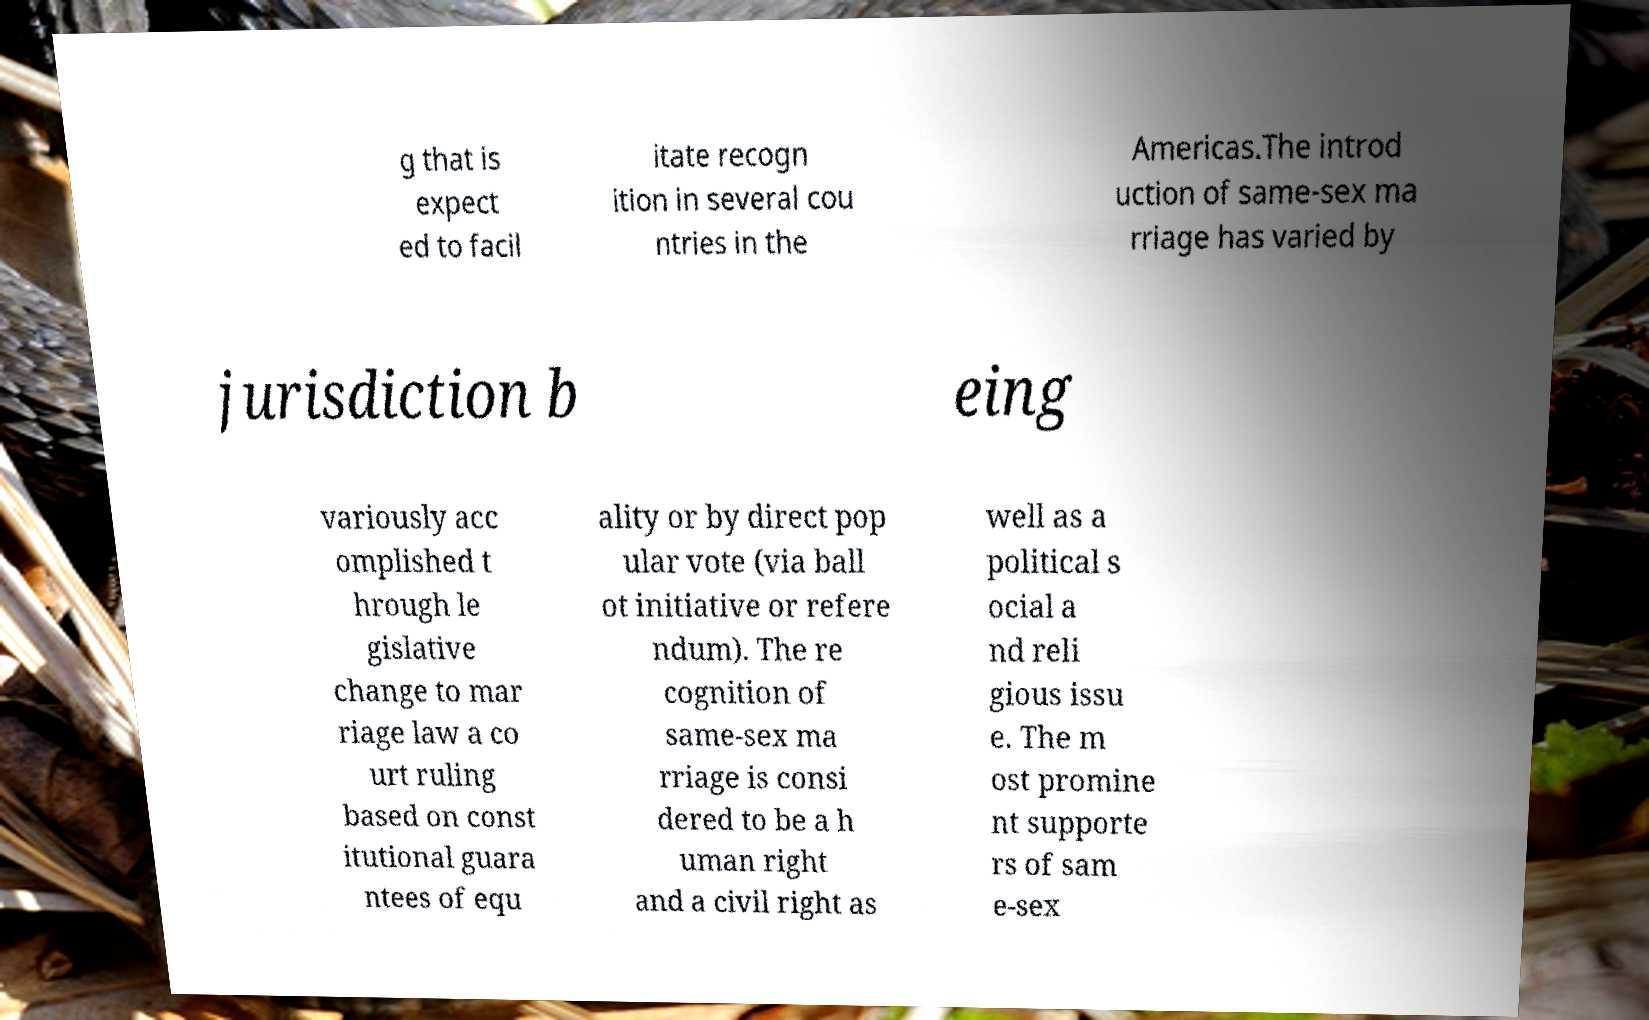There's text embedded in this image that I need extracted. Can you transcribe it verbatim? g that is expect ed to facil itate recogn ition in several cou ntries in the Americas.The introd uction of same-sex ma rriage has varied by jurisdiction b eing variously acc omplished t hrough le gislative change to mar riage law a co urt ruling based on const itutional guara ntees of equ ality or by direct pop ular vote (via ball ot initiative or refere ndum). The re cognition of same-sex ma rriage is consi dered to be a h uman right and a civil right as well as a political s ocial a nd reli gious issu e. The m ost promine nt supporte rs of sam e-sex 